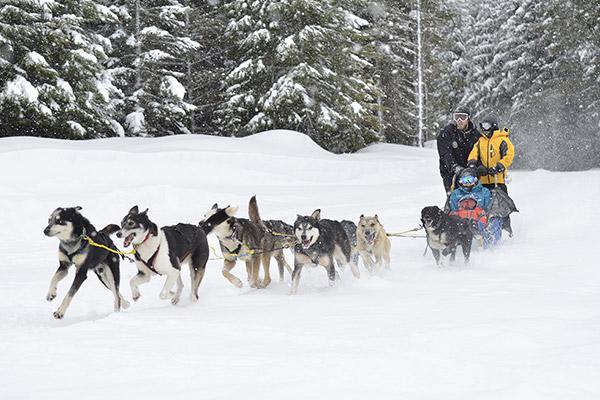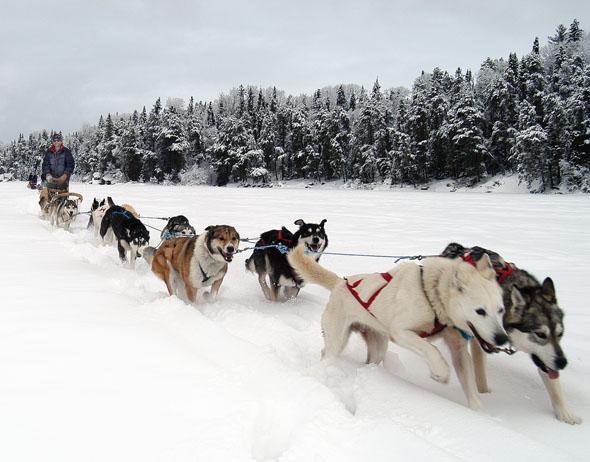The first image is the image on the left, the second image is the image on the right. Evaluate the accuracy of this statement regarding the images: "In one image, the sled driver wears a bright red jacket.". Is it true? Answer yes or no. No. The first image is the image on the left, the second image is the image on the right. For the images displayed, is the sentence "There is a person in a red coat in the image on the right." factually correct? Answer yes or no. No. 